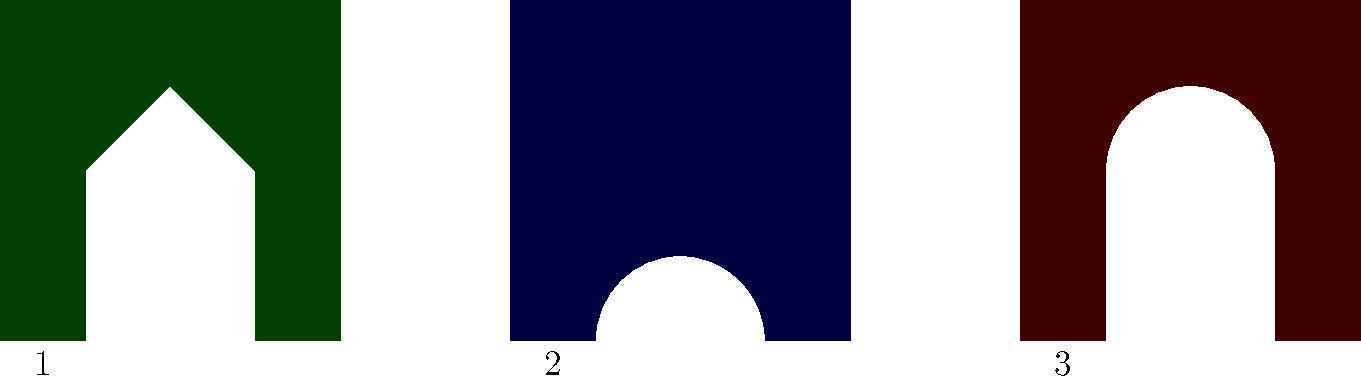As an art curator, you're preparing an exhibition on ancient architectural styles. Based on the silhouette outlines provided, which number represents the most likely example of Gothic architecture? To identify Gothic architecture from the silhouettes, we need to consider the key features of this style:

1. Gothic architecture is characterized by its emphasis on height and vertical lines.
2. It often features pointed arches, which are a hallmark of the style.
3. Gothic buildings typically have large windows and intricate details.

Analyzing the silhouettes:

1. Silhouette 1 (green): This shape has a triangular top, which could represent a pediment. The overall form is more indicative of Classical or Neo-Classical architecture.

2. Silhouette 2 (blue): This shape has a curved top, which might represent a dome or barrel vault. This is more characteristic of Romanesque or Renaissance architecture.

3. Silhouette 3 (red): This silhouette shows a tall, pointed shape in the center, which is likely representing a spire or a pointed arch. The vertical emphasis and the pointed element are strong indicators of Gothic architecture.

Given these observations, the silhouette that most closely aligns with Gothic architectural characteristics is number 3.
Answer: 3 